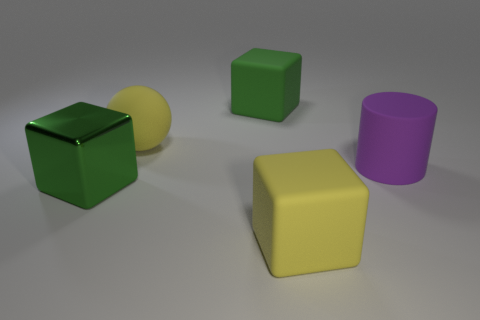Subtract all yellow blocks. How many blocks are left? 2 Subtract all green balls. How many green blocks are left? 2 Subtract all green cubes. How many cubes are left? 1 Add 4 large purple matte cylinders. How many objects exist? 9 Subtract all cubes. How many objects are left? 2 Subtract 1 spheres. How many spheres are left? 0 Subtract all blue cylinders. Subtract all red spheres. How many cylinders are left? 1 Subtract all big purple cylinders. Subtract all yellow matte spheres. How many objects are left? 3 Add 1 large yellow rubber cubes. How many large yellow rubber cubes are left? 2 Add 1 tiny cyan things. How many tiny cyan things exist? 1 